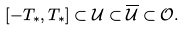<formula> <loc_0><loc_0><loc_500><loc_500>[ - T _ { * } , T _ { * } ] \subset { \mathcal { U } } \subset \overline { \mathcal { U } } \subset { \mathcal { O } } .</formula> 